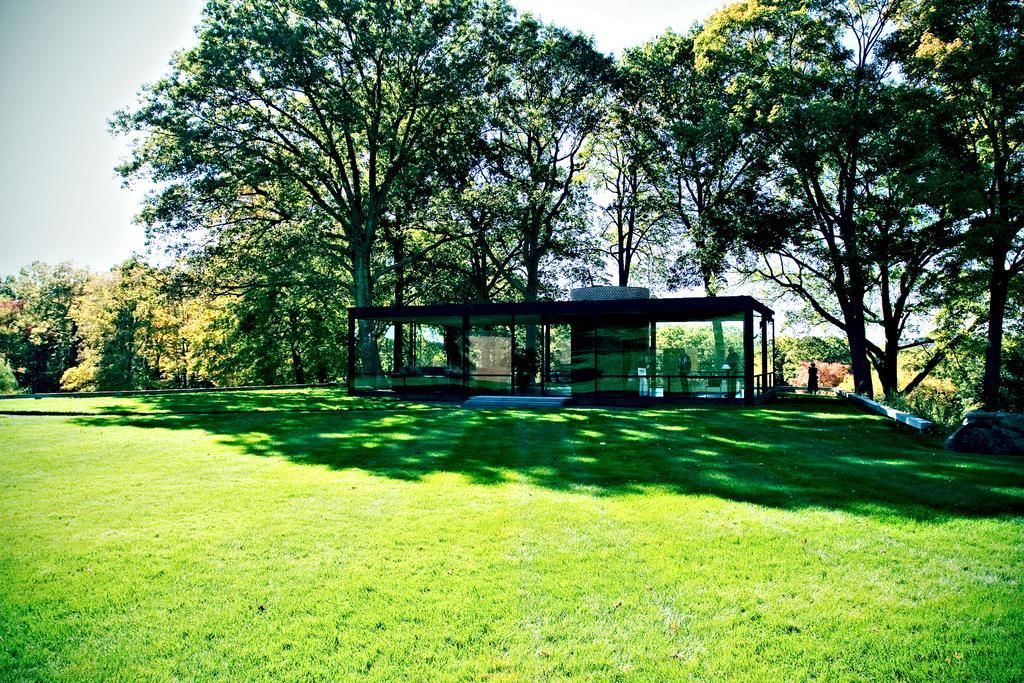Please provide a concise description of this image. Here in this picture we can see the ground is fully covered with grass over there and in the middle we can see a shed present, that is covered with glass doors around it and we can see people standing under that over there and we can also see plants and trees present all over there. 